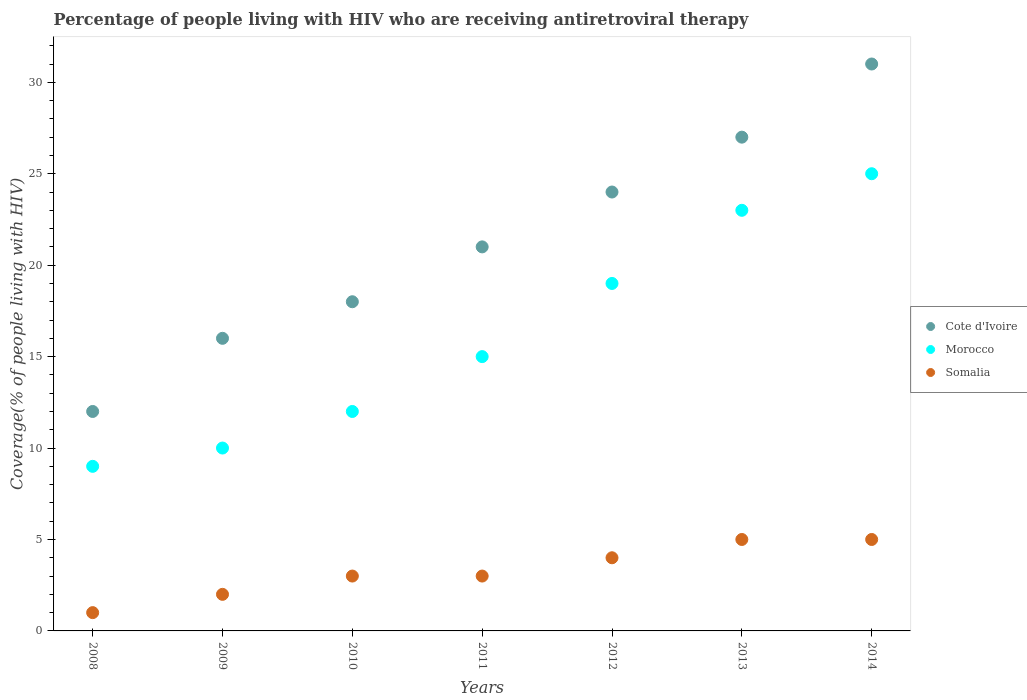How many different coloured dotlines are there?
Keep it short and to the point. 3. Is the number of dotlines equal to the number of legend labels?
Offer a terse response. Yes. What is the percentage of the HIV infected people who are receiving antiretroviral therapy in Cote d'Ivoire in 2012?
Ensure brevity in your answer.  24. Across all years, what is the maximum percentage of the HIV infected people who are receiving antiretroviral therapy in Cote d'Ivoire?
Offer a very short reply. 31. Across all years, what is the minimum percentage of the HIV infected people who are receiving antiretroviral therapy in Somalia?
Keep it short and to the point. 1. In which year was the percentage of the HIV infected people who are receiving antiretroviral therapy in Somalia minimum?
Make the answer very short. 2008. What is the total percentage of the HIV infected people who are receiving antiretroviral therapy in Somalia in the graph?
Offer a very short reply. 23. What is the difference between the percentage of the HIV infected people who are receiving antiretroviral therapy in Somalia in 2012 and that in 2014?
Provide a succinct answer. -1. What is the difference between the percentage of the HIV infected people who are receiving antiretroviral therapy in Cote d'Ivoire in 2013 and the percentage of the HIV infected people who are receiving antiretroviral therapy in Morocco in 2008?
Make the answer very short. 18. What is the average percentage of the HIV infected people who are receiving antiretroviral therapy in Morocco per year?
Your answer should be very brief. 16.14. In the year 2012, what is the difference between the percentage of the HIV infected people who are receiving antiretroviral therapy in Morocco and percentage of the HIV infected people who are receiving antiretroviral therapy in Somalia?
Your answer should be very brief. 15. Is the percentage of the HIV infected people who are receiving antiretroviral therapy in Somalia in 2008 less than that in 2012?
Offer a terse response. Yes. What is the difference between the highest and the lowest percentage of the HIV infected people who are receiving antiretroviral therapy in Cote d'Ivoire?
Keep it short and to the point. 19. In how many years, is the percentage of the HIV infected people who are receiving antiretroviral therapy in Somalia greater than the average percentage of the HIV infected people who are receiving antiretroviral therapy in Somalia taken over all years?
Your answer should be very brief. 3. Is it the case that in every year, the sum of the percentage of the HIV infected people who are receiving antiretroviral therapy in Cote d'Ivoire and percentage of the HIV infected people who are receiving antiretroviral therapy in Morocco  is greater than the percentage of the HIV infected people who are receiving antiretroviral therapy in Somalia?
Give a very brief answer. Yes. Does the percentage of the HIV infected people who are receiving antiretroviral therapy in Cote d'Ivoire monotonically increase over the years?
Offer a very short reply. Yes. How many dotlines are there?
Provide a short and direct response. 3. What is the difference between two consecutive major ticks on the Y-axis?
Ensure brevity in your answer.  5. Are the values on the major ticks of Y-axis written in scientific E-notation?
Ensure brevity in your answer.  No. Does the graph contain any zero values?
Your answer should be very brief. No. How are the legend labels stacked?
Provide a succinct answer. Vertical. What is the title of the graph?
Make the answer very short. Percentage of people living with HIV who are receiving antiretroviral therapy. What is the label or title of the X-axis?
Make the answer very short. Years. What is the label or title of the Y-axis?
Make the answer very short. Coverage(% of people living with HIV). What is the Coverage(% of people living with HIV) of Cote d'Ivoire in 2008?
Give a very brief answer. 12. What is the Coverage(% of people living with HIV) of Somalia in 2008?
Make the answer very short. 1. What is the Coverage(% of people living with HIV) of Morocco in 2009?
Ensure brevity in your answer.  10. What is the Coverage(% of people living with HIV) of Cote d'Ivoire in 2010?
Offer a very short reply. 18. What is the Coverage(% of people living with HIV) in Morocco in 2010?
Provide a short and direct response. 12. What is the Coverage(% of people living with HIV) in Somalia in 2010?
Provide a succinct answer. 3. What is the Coverage(% of people living with HIV) in Cote d'Ivoire in 2011?
Give a very brief answer. 21. What is the Coverage(% of people living with HIV) in Morocco in 2011?
Give a very brief answer. 15. What is the Coverage(% of people living with HIV) of Cote d'Ivoire in 2013?
Provide a short and direct response. 27. What is the Coverage(% of people living with HIV) of Morocco in 2013?
Give a very brief answer. 23. What is the Coverage(% of people living with HIV) of Somalia in 2013?
Give a very brief answer. 5. What is the Coverage(% of people living with HIV) of Morocco in 2014?
Provide a succinct answer. 25. What is the Coverage(% of people living with HIV) of Somalia in 2014?
Your answer should be compact. 5. Across all years, what is the minimum Coverage(% of people living with HIV) in Cote d'Ivoire?
Offer a terse response. 12. Across all years, what is the minimum Coverage(% of people living with HIV) in Morocco?
Your answer should be compact. 9. What is the total Coverage(% of people living with HIV) in Cote d'Ivoire in the graph?
Your response must be concise. 149. What is the total Coverage(% of people living with HIV) in Morocco in the graph?
Make the answer very short. 113. What is the difference between the Coverage(% of people living with HIV) in Cote d'Ivoire in 2008 and that in 2009?
Offer a terse response. -4. What is the difference between the Coverage(% of people living with HIV) of Morocco in 2008 and that in 2009?
Offer a very short reply. -1. What is the difference between the Coverage(% of people living with HIV) of Somalia in 2008 and that in 2009?
Make the answer very short. -1. What is the difference between the Coverage(% of people living with HIV) in Cote d'Ivoire in 2008 and that in 2010?
Provide a short and direct response. -6. What is the difference between the Coverage(% of people living with HIV) in Morocco in 2008 and that in 2010?
Offer a terse response. -3. What is the difference between the Coverage(% of people living with HIV) of Morocco in 2008 and that in 2011?
Keep it short and to the point. -6. What is the difference between the Coverage(% of people living with HIV) in Cote d'Ivoire in 2008 and that in 2012?
Your response must be concise. -12. What is the difference between the Coverage(% of people living with HIV) of Morocco in 2008 and that in 2013?
Provide a succinct answer. -14. What is the difference between the Coverage(% of people living with HIV) of Somalia in 2008 and that in 2014?
Provide a short and direct response. -4. What is the difference between the Coverage(% of people living with HIV) of Somalia in 2009 and that in 2010?
Keep it short and to the point. -1. What is the difference between the Coverage(% of people living with HIV) in Morocco in 2009 and that in 2011?
Your answer should be very brief. -5. What is the difference between the Coverage(% of people living with HIV) of Somalia in 2009 and that in 2011?
Your answer should be very brief. -1. What is the difference between the Coverage(% of people living with HIV) of Cote d'Ivoire in 2009 and that in 2012?
Provide a succinct answer. -8. What is the difference between the Coverage(% of people living with HIV) in Somalia in 2009 and that in 2012?
Provide a short and direct response. -2. What is the difference between the Coverage(% of people living with HIV) of Cote d'Ivoire in 2009 and that in 2013?
Ensure brevity in your answer.  -11. What is the difference between the Coverage(% of people living with HIV) in Morocco in 2009 and that in 2013?
Offer a very short reply. -13. What is the difference between the Coverage(% of people living with HIV) of Somalia in 2009 and that in 2013?
Give a very brief answer. -3. What is the difference between the Coverage(% of people living with HIV) in Morocco in 2009 and that in 2014?
Your answer should be compact. -15. What is the difference between the Coverage(% of people living with HIV) of Cote d'Ivoire in 2010 and that in 2011?
Ensure brevity in your answer.  -3. What is the difference between the Coverage(% of people living with HIV) of Morocco in 2010 and that in 2011?
Provide a succinct answer. -3. What is the difference between the Coverage(% of people living with HIV) in Somalia in 2010 and that in 2011?
Your answer should be very brief. 0. What is the difference between the Coverage(% of people living with HIV) of Cote d'Ivoire in 2010 and that in 2012?
Give a very brief answer. -6. What is the difference between the Coverage(% of people living with HIV) in Cote d'Ivoire in 2010 and that in 2013?
Keep it short and to the point. -9. What is the difference between the Coverage(% of people living with HIV) of Cote d'Ivoire in 2010 and that in 2014?
Provide a succinct answer. -13. What is the difference between the Coverage(% of people living with HIV) in Morocco in 2010 and that in 2014?
Offer a terse response. -13. What is the difference between the Coverage(% of people living with HIV) in Cote d'Ivoire in 2011 and that in 2012?
Your answer should be very brief. -3. What is the difference between the Coverage(% of people living with HIV) in Cote d'Ivoire in 2011 and that in 2013?
Ensure brevity in your answer.  -6. What is the difference between the Coverage(% of people living with HIV) in Morocco in 2011 and that in 2014?
Your answer should be compact. -10. What is the difference between the Coverage(% of people living with HIV) in Somalia in 2011 and that in 2014?
Offer a terse response. -2. What is the difference between the Coverage(% of people living with HIV) of Cote d'Ivoire in 2012 and that in 2013?
Provide a short and direct response. -3. What is the difference between the Coverage(% of people living with HIV) in Morocco in 2012 and that in 2013?
Your response must be concise. -4. What is the difference between the Coverage(% of people living with HIV) in Somalia in 2012 and that in 2013?
Provide a succinct answer. -1. What is the difference between the Coverage(% of people living with HIV) of Cote d'Ivoire in 2012 and that in 2014?
Your response must be concise. -7. What is the difference between the Coverage(% of people living with HIV) of Morocco in 2012 and that in 2014?
Your answer should be compact. -6. What is the difference between the Coverage(% of people living with HIV) in Cote d'Ivoire in 2013 and that in 2014?
Ensure brevity in your answer.  -4. What is the difference between the Coverage(% of people living with HIV) in Cote d'Ivoire in 2008 and the Coverage(% of people living with HIV) in Morocco in 2009?
Provide a short and direct response. 2. What is the difference between the Coverage(% of people living with HIV) in Cote d'Ivoire in 2008 and the Coverage(% of people living with HIV) in Somalia in 2009?
Your answer should be compact. 10. What is the difference between the Coverage(% of people living with HIV) of Morocco in 2008 and the Coverage(% of people living with HIV) of Somalia in 2010?
Your answer should be very brief. 6. What is the difference between the Coverage(% of people living with HIV) of Cote d'Ivoire in 2008 and the Coverage(% of people living with HIV) of Morocco in 2013?
Give a very brief answer. -11. What is the difference between the Coverage(% of people living with HIV) of Cote d'Ivoire in 2008 and the Coverage(% of people living with HIV) of Somalia in 2013?
Make the answer very short. 7. What is the difference between the Coverage(% of people living with HIV) in Morocco in 2008 and the Coverage(% of people living with HIV) in Somalia in 2013?
Make the answer very short. 4. What is the difference between the Coverage(% of people living with HIV) of Morocco in 2008 and the Coverage(% of people living with HIV) of Somalia in 2014?
Give a very brief answer. 4. What is the difference between the Coverage(% of people living with HIV) of Cote d'Ivoire in 2009 and the Coverage(% of people living with HIV) of Morocco in 2010?
Your answer should be very brief. 4. What is the difference between the Coverage(% of people living with HIV) in Cote d'Ivoire in 2009 and the Coverage(% of people living with HIV) in Somalia in 2010?
Your answer should be very brief. 13. What is the difference between the Coverage(% of people living with HIV) of Morocco in 2009 and the Coverage(% of people living with HIV) of Somalia in 2010?
Offer a very short reply. 7. What is the difference between the Coverage(% of people living with HIV) in Cote d'Ivoire in 2009 and the Coverage(% of people living with HIV) in Morocco in 2011?
Offer a terse response. 1. What is the difference between the Coverage(% of people living with HIV) in Morocco in 2009 and the Coverage(% of people living with HIV) in Somalia in 2011?
Make the answer very short. 7. What is the difference between the Coverage(% of people living with HIV) of Cote d'Ivoire in 2009 and the Coverage(% of people living with HIV) of Somalia in 2012?
Keep it short and to the point. 12. What is the difference between the Coverage(% of people living with HIV) in Morocco in 2009 and the Coverage(% of people living with HIV) in Somalia in 2012?
Your answer should be compact. 6. What is the difference between the Coverage(% of people living with HIV) in Cote d'Ivoire in 2009 and the Coverage(% of people living with HIV) in Morocco in 2013?
Offer a terse response. -7. What is the difference between the Coverage(% of people living with HIV) of Cote d'Ivoire in 2009 and the Coverage(% of people living with HIV) of Somalia in 2013?
Provide a succinct answer. 11. What is the difference between the Coverage(% of people living with HIV) of Morocco in 2009 and the Coverage(% of people living with HIV) of Somalia in 2013?
Ensure brevity in your answer.  5. What is the difference between the Coverage(% of people living with HIV) of Cote d'Ivoire in 2009 and the Coverage(% of people living with HIV) of Morocco in 2014?
Provide a short and direct response. -9. What is the difference between the Coverage(% of people living with HIV) of Cote d'Ivoire in 2010 and the Coverage(% of people living with HIV) of Morocco in 2011?
Provide a short and direct response. 3. What is the difference between the Coverage(% of people living with HIV) in Cote d'Ivoire in 2010 and the Coverage(% of people living with HIV) in Somalia in 2011?
Your answer should be compact. 15. What is the difference between the Coverage(% of people living with HIV) in Morocco in 2010 and the Coverage(% of people living with HIV) in Somalia in 2011?
Make the answer very short. 9. What is the difference between the Coverage(% of people living with HIV) of Cote d'Ivoire in 2010 and the Coverage(% of people living with HIV) of Morocco in 2012?
Keep it short and to the point. -1. What is the difference between the Coverage(% of people living with HIV) in Cote d'Ivoire in 2010 and the Coverage(% of people living with HIV) in Somalia in 2012?
Give a very brief answer. 14. What is the difference between the Coverage(% of people living with HIV) in Cote d'Ivoire in 2010 and the Coverage(% of people living with HIV) in Morocco in 2013?
Your response must be concise. -5. What is the difference between the Coverage(% of people living with HIV) in Cote d'Ivoire in 2010 and the Coverage(% of people living with HIV) in Somalia in 2014?
Provide a short and direct response. 13. What is the difference between the Coverage(% of people living with HIV) of Morocco in 2010 and the Coverage(% of people living with HIV) of Somalia in 2014?
Make the answer very short. 7. What is the difference between the Coverage(% of people living with HIV) in Cote d'Ivoire in 2011 and the Coverage(% of people living with HIV) in Morocco in 2012?
Offer a very short reply. 2. What is the difference between the Coverage(% of people living with HIV) in Cote d'Ivoire in 2011 and the Coverage(% of people living with HIV) in Somalia in 2013?
Provide a succinct answer. 16. What is the difference between the Coverage(% of people living with HIV) of Morocco in 2011 and the Coverage(% of people living with HIV) of Somalia in 2013?
Your answer should be compact. 10. What is the difference between the Coverage(% of people living with HIV) in Cote d'Ivoire in 2011 and the Coverage(% of people living with HIV) in Morocco in 2014?
Your response must be concise. -4. What is the difference between the Coverage(% of people living with HIV) of Morocco in 2012 and the Coverage(% of people living with HIV) of Somalia in 2013?
Your answer should be compact. 14. What is the difference between the Coverage(% of people living with HIV) of Cote d'Ivoire in 2012 and the Coverage(% of people living with HIV) of Somalia in 2014?
Give a very brief answer. 19. What is the difference between the Coverage(% of people living with HIV) of Cote d'Ivoire in 2013 and the Coverage(% of people living with HIV) of Morocco in 2014?
Provide a succinct answer. 2. What is the difference between the Coverage(% of people living with HIV) of Morocco in 2013 and the Coverage(% of people living with HIV) of Somalia in 2014?
Give a very brief answer. 18. What is the average Coverage(% of people living with HIV) in Cote d'Ivoire per year?
Provide a succinct answer. 21.29. What is the average Coverage(% of people living with HIV) of Morocco per year?
Provide a succinct answer. 16.14. What is the average Coverage(% of people living with HIV) in Somalia per year?
Give a very brief answer. 3.29. In the year 2008, what is the difference between the Coverage(% of people living with HIV) in Cote d'Ivoire and Coverage(% of people living with HIV) in Morocco?
Provide a short and direct response. 3. In the year 2008, what is the difference between the Coverage(% of people living with HIV) of Morocco and Coverage(% of people living with HIV) of Somalia?
Ensure brevity in your answer.  8. In the year 2009, what is the difference between the Coverage(% of people living with HIV) in Cote d'Ivoire and Coverage(% of people living with HIV) in Morocco?
Your answer should be very brief. 6. In the year 2009, what is the difference between the Coverage(% of people living with HIV) in Morocco and Coverage(% of people living with HIV) in Somalia?
Provide a short and direct response. 8. In the year 2010, what is the difference between the Coverage(% of people living with HIV) in Cote d'Ivoire and Coverage(% of people living with HIV) in Morocco?
Offer a very short reply. 6. In the year 2011, what is the difference between the Coverage(% of people living with HIV) in Cote d'Ivoire and Coverage(% of people living with HIV) in Morocco?
Keep it short and to the point. 6. In the year 2011, what is the difference between the Coverage(% of people living with HIV) of Morocco and Coverage(% of people living with HIV) of Somalia?
Your answer should be very brief. 12. In the year 2012, what is the difference between the Coverage(% of people living with HIV) of Cote d'Ivoire and Coverage(% of people living with HIV) of Somalia?
Provide a succinct answer. 20. In the year 2014, what is the difference between the Coverage(% of people living with HIV) of Cote d'Ivoire and Coverage(% of people living with HIV) of Morocco?
Your answer should be very brief. 6. In the year 2014, what is the difference between the Coverage(% of people living with HIV) in Cote d'Ivoire and Coverage(% of people living with HIV) in Somalia?
Make the answer very short. 26. What is the ratio of the Coverage(% of people living with HIV) in Cote d'Ivoire in 2008 to that in 2009?
Your answer should be compact. 0.75. What is the ratio of the Coverage(% of people living with HIV) in Morocco in 2008 to that in 2009?
Your answer should be compact. 0.9. What is the ratio of the Coverage(% of people living with HIV) in Cote d'Ivoire in 2008 to that in 2010?
Offer a very short reply. 0.67. What is the ratio of the Coverage(% of people living with HIV) in Cote d'Ivoire in 2008 to that in 2011?
Your answer should be compact. 0.57. What is the ratio of the Coverage(% of people living with HIV) of Somalia in 2008 to that in 2011?
Keep it short and to the point. 0.33. What is the ratio of the Coverage(% of people living with HIV) of Morocco in 2008 to that in 2012?
Give a very brief answer. 0.47. What is the ratio of the Coverage(% of people living with HIV) in Somalia in 2008 to that in 2012?
Your answer should be very brief. 0.25. What is the ratio of the Coverage(% of people living with HIV) of Cote d'Ivoire in 2008 to that in 2013?
Your answer should be compact. 0.44. What is the ratio of the Coverage(% of people living with HIV) in Morocco in 2008 to that in 2013?
Offer a very short reply. 0.39. What is the ratio of the Coverage(% of people living with HIV) of Cote d'Ivoire in 2008 to that in 2014?
Your answer should be compact. 0.39. What is the ratio of the Coverage(% of people living with HIV) of Morocco in 2008 to that in 2014?
Provide a short and direct response. 0.36. What is the ratio of the Coverage(% of people living with HIV) of Cote d'Ivoire in 2009 to that in 2010?
Offer a terse response. 0.89. What is the ratio of the Coverage(% of people living with HIV) of Somalia in 2009 to that in 2010?
Ensure brevity in your answer.  0.67. What is the ratio of the Coverage(% of people living with HIV) in Cote d'Ivoire in 2009 to that in 2011?
Ensure brevity in your answer.  0.76. What is the ratio of the Coverage(% of people living with HIV) in Morocco in 2009 to that in 2011?
Your answer should be compact. 0.67. What is the ratio of the Coverage(% of people living with HIV) in Cote d'Ivoire in 2009 to that in 2012?
Your answer should be compact. 0.67. What is the ratio of the Coverage(% of people living with HIV) of Morocco in 2009 to that in 2012?
Your answer should be very brief. 0.53. What is the ratio of the Coverage(% of people living with HIV) of Cote d'Ivoire in 2009 to that in 2013?
Your answer should be very brief. 0.59. What is the ratio of the Coverage(% of people living with HIV) of Morocco in 2009 to that in 2013?
Your answer should be compact. 0.43. What is the ratio of the Coverage(% of people living with HIV) in Cote d'Ivoire in 2009 to that in 2014?
Ensure brevity in your answer.  0.52. What is the ratio of the Coverage(% of people living with HIV) in Morocco in 2009 to that in 2014?
Make the answer very short. 0.4. What is the ratio of the Coverage(% of people living with HIV) of Somalia in 2009 to that in 2014?
Provide a succinct answer. 0.4. What is the ratio of the Coverage(% of people living with HIV) in Somalia in 2010 to that in 2011?
Offer a terse response. 1. What is the ratio of the Coverage(% of people living with HIV) of Cote d'Ivoire in 2010 to that in 2012?
Provide a short and direct response. 0.75. What is the ratio of the Coverage(% of people living with HIV) of Morocco in 2010 to that in 2012?
Offer a terse response. 0.63. What is the ratio of the Coverage(% of people living with HIV) of Cote d'Ivoire in 2010 to that in 2013?
Keep it short and to the point. 0.67. What is the ratio of the Coverage(% of people living with HIV) of Morocco in 2010 to that in 2013?
Provide a succinct answer. 0.52. What is the ratio of the Coverage(% of people living with HIV) in Cote d'Ivoire in 2010 to that in 2014?
Provide a short and direct response. 0.58. What is the ratio of the Coverage(% of people living with HIV) of Morocco in 2010 to that in 2014?
Ensure brevity in your answer.  0.48. What is the ratio of the Coverage(% of people living with HIV) of Somalia in 2010 to that in 2014?
Provide a short and direct response. 0.6. What is the ratio of the Coverage(% of people living with HIV) in Cote d'Ivoire in 2011 to that in 2012?
Give a very brief answer. 0.88. What is the ratio of the Coverage(% of people living with HIV) of Morocco in 2011 to that in 2012?
Your response must be concise. 0.79. What is the ratio of the Coverage(% of people living with HIV) in Somalia in 2011 to that in 2012?
Provide a short and direct response. 0.75. What is the ratio of the Coverage(% of people living with HIV) in Cote d'Ivoire in 2011 to that in 2013?
Provide a short and direct response. 0.78. What is the ratio of the Coverage(% of people living with HIV) in Morocco in 2011 to that in 2013?
Ensure brevity in your answer.  0.65. What is the ratio of the Coverage(% of people living with HIV) of Somalia in 2011 to that in 2013?
Keep it short and to the point. 0.6. What is the ratio of the Coverage(% of people living with HIV) of Cote d'Ivoire in 2011 to that in 2014?
Your response must be concise. 0.68. What is the ratio of the Coverage(% of people living with HIV) in Morocco in 2011 to that in 2014?
Your answer should be compact. 0.6. What is the ratio of the Coverage(% of people living with HIV) in Somalia in 2011 to that in 2014?
Your answer should be compact. 0.6. What is the ratio of the Coverage(% of people living with HIV) of Cote d'Ivoire in 2012 to that in 2013?
Make the answer very short. 0.89. What is the ratio of the Coverage(% of people living with HIV) in Morocco in 2012 to that in 2013?
Provide a short and direct response. 0.83. What is the ratio of the Coverage(% of people living with HIV) of Cote d'Ivoire in 2012 to that in 2014?
Offer a very short reply. 0.77. What is the ratio of the Coverage(% of people living with HIV) of Morocco in 2012 to that in 2014?
Ensure brevity in your answer.  0.76. What is the ratio of the Coverage(% of people living with HIV) in Somalia in 2012 to that in 2014?
Ensure brevity in your answer.  0.8. What is the ratio of the Coverage(% of people living with HIV) of Cote d'Ivoire in 2013 to that in 2014?
Your response must be concise. 0.87. What is the ratio of the Coverage(% of people living with HIV) in Morocco in 2013 to that in 2014?
Offer a terse response. 0.92. What is the difference between the highest and the second highest Coverage(% of people living with HIV) of Cote d'Ivoire?
Offer a very short reply. 4. What is the difference between the highest and the second highest Coverage(% of people living with HIV) of Morocco?
Offer a terse response. 2. What is the difference between the highest and the lowest Coverage(% of people living with HIV) of Cote d'Ivoire?
Offer a very short reply. 19. What is the difference between the highest and the lowest Coverage(% of people living with HIV) of Morocco?
Your answer should be very brief. 16. What is the difference between the highest and the lowest Coverage(% of people living with HIV) of Somalia?
Give a very brief answer. 4. 